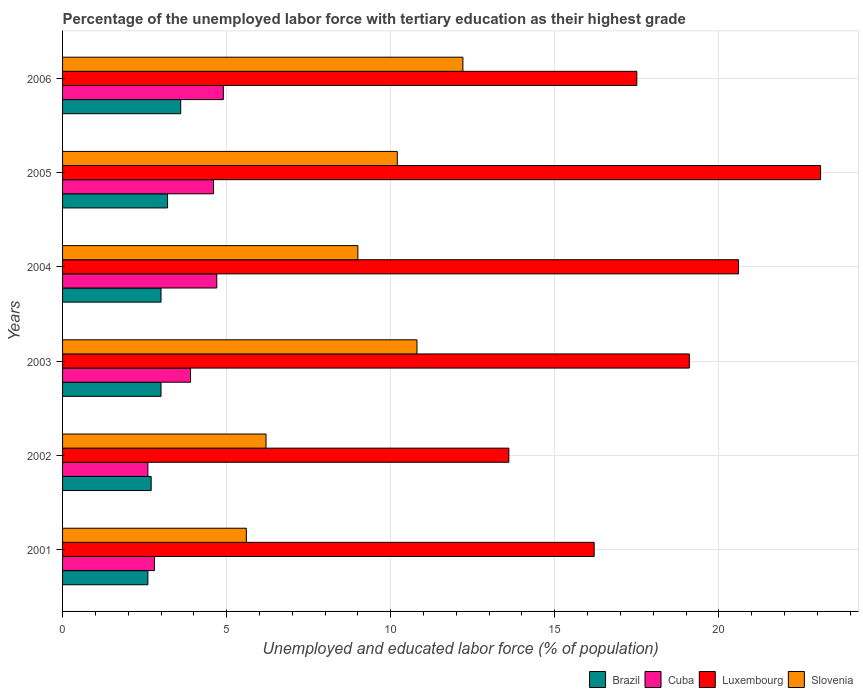How many different coloured bars are there?
Ensure brevity in your answer.  4. How many groups of bars are there?
Your response must be concise. 6. Are the number of bars on each tick of the Y-axis equal?
Keep it short and to the point. Yes. What is the label of the 1st group of bars from the top?
Give a very brief answer. 2006. What is the percentage of the unemployed labor force with tertiary education in Brazil in 2002?
Offer a terse response. 2.7. Across all years, what is the maximum percentage of the unemployed labor force with tertiary education in Slovenia?
Your response must be concise. 12.2. Across all years, what is the minimum percentage of the unemployed labor force with tertiary education in Cuba?
Your response must be concise. 2.6. In which year was the percentage of the unemployed labor force with tertiary education in Slovenia maximum?
Keep it short and to the point. 2006. What is the total percentage of the unemployed labor force with tertiary education in Slovenia in the graph?
Make the answer very short. 54. What is the difference between the percentage of the unemployed labor force with tertiary education in Slovenia in 2004 and that in 2006?
Your answer should be very brief. -3.2. What is the difference between the percentage of the unemployed labor force with tertiary education in Cuba in 2006 and the percentage of the unemployed labor force with tertiary education in Slovenia in 2001?
Keep it short and to the point. -0.7. What is the average percentage of the unemployed labor force with tertiary education in Slovenia per year?
Your answer should be compact. 9. In the year 2003, what is the difference between the percentage of the unemployed labor force with tertiary education in Slovenia and percentage of the unemployed labor force with tertiary education in Cuba?
Make the answer very short. 6.9. What is the ratio of the percentage of the unemployed labor force with tertiary education in Luxembourg in 2002 to that in 2006?
Provide a short and direct response. 0.78. Is the percentage of the unemployed labor force with tertiary education in Slovenia in 2004 less than that in 2005?
Offer a very short reply. Yes. What is the difference between the highest and the second highest percentage of the unemployed labor force with tertiary education in Cuba?
Offer a terse response. 0.2. What is the difference between the highest and the lowest percentage of the unemployed labor force with tertiary education in Cuba?
Offer a terse response. 2.3. In how many years, is the percentage of the unemployed labor force with tertiary education in Slovenia greater than the average percentage of the unemployed labor force with tertiary education in Slovenia taken over all years?
Your answer should be compact. 4. Is the sum of the percentage of the unemployed labor force with tertiary education in Brazil in 2002 and 2004 greater than the maximum percentage of the unemployed labor force with tertiary education in Slovenia across all years?
Your answer should be very brief. No. What does the 2nd bar from the top in 2001 represents?
Make the answer very short. Luxembourg. What does the 1st bar from the bottom in 2005 represents?
Keep it short and to the point. Brazil. How many bars are there?
Your response must be concise. 24. What is the difference between two consecutive major ticks on the X-axis?
Give a very brief answer. 5. How many legend labels are there?
Your answer should be very brief. 4. How are the legend labels stacked?
Give a very brief answer. Horizontal. What is the title of the graph?
Offer a very short reply. Percentage of the unemployed labor force with tertiary education as their highest grade. Does "Timor-Leste" appear as one of the legend labels in the graph?
Offer a very short reply. No. What is the label or title of the X-axis?
Ensure brevity in your answer.  Unemployed and educated labor force (% of population). What is the Unemployed and educated labor force (% of population) of Brazil in 2001?
Offer a terse response. 2.6. What is the Unemployed and educated labor force (% of population) in Cuba in 2001?
Your response must be concise. 2.8. What is the Unemployed and educated labor force (% of population) of Luxembourg in 2001?
Ensure brevity in your answer.  16.2. What is the Unemployed and educated labor force (% of population) of Slovenia in 2001?
Keep it short and to the point. 5.6. What is the Unemployed and educated labor force (% of population) of Brazil in 2002?
Make the answer very short. 2.7. What is the Unemployed and educated labor force (% of population) of Cuba in 2002?
Offer a very short reply. 2.6. What is the Unemployed and educated labor force (% of population) of Luxembourg in 2002?
Give a very brief answer. 13.6. What is the Unemployed and educated labor force (% of population) in Slovenia in 2002?
Keep it short and to the point. 6.2. What is the Unemployed and educated labor force (% of population) of Cuba in 2003?
Your answer should be very brief. 3.9. What is the Unemployed and educated labor force (% of population) in Luxembourg in 2003?
Ensure brevity in your answer.  19.1. What is the Unemployed and educated labor force (% of population) of Slovenia in 2003?
Offer a terse response. 10.8. What is the Unemployed and educated labor force (% of population) of Brazil in 2004?
Your answer should be very brief. 3. What is the Unemployed and educated labor force (% of population) of Cuba in 2004?
Your answer should be very brief. 4.7. What is the Unemployed and educated labor force (% of population) in Luxembourg in 2004?
Keep it short and to the point. 20.6. What is the Unemployed and educated labor force (% of population) of Slovenia in 2004?
Offer a very short reply. 9. What is the Unemployed and educated labor force (% of population) in Brazil in 2005?
Offer a very short reply. 3.2. What is the Unemployed and educated labor force (% of population) of Cuba in 2005?
Provide a short and direct response. 4.6. What is the Unemployed and educated labor force (% of population) in Luxembourg in 2005?
Your answer should be very brief. 23.1. What is the Unemployed and educated labor force (% of population) of Slovenia in 2005?
Make the answer very short. 10.2. What is the Unemployed and educated labor force (% of population) in Brazil in 2006?
Offer a very short reply. 3.6. What is the Unemployed and educated labor force (% of population) of Cuba in 2006?
Provide a short and direct response. 4.9. What is the Unemployed and educated labor force (% of population) in Slovenia in 2006?
Give a very brief answer. 12.2. Across all years, what is the maximum Unemployed and educated labor force (% of population) in Brazil?
Provide a succinct answer. 3.6. Across all years, what is the maximum Unemployed and educated labor force (% of population) of Cuba?
Your answer should be very brief. 4.9. Across all years, what is the maximum Unemployed and educated labor force (% of population) in Luxembourg?
Provide a short and direct response. 23.1. Across all years, what is the maximum Unemployed and educated labor force (% of population) in Slovenia?
Provide a succinct answer. 12.2. Across all years, what is the minimum Unemployed and educated labor force (% of population) in Brazil?
Provide a short and direct response. 2.6. Across all years, what is the minimum Unemployed and educated labor force (% of population) in Cuba?
Keep it short and to the point. 2.6. Across all years, what is the minimum Unemployed and educated labor force (% of population) in Luxembourg?
Make the answer very short. 13.6. Across all years, what is the minimum Unemployed and educated labor force (% of population) in Slovenia?
Provide a short and direct response. 5.6. What is the total Unemployed and educated labor force (% of population) of Brazil in the graph?
Your answer should be very brief. 18.1. What is the total Unemployed and educated labor force (% of population) of Luxembourg in the graph?
Your answer should be very brief. 110.1. What is the difference between the Unemployed and educated labor force (% of population) in Brazil in 2001 and that in 2002?
Your response must be concise. -0.1. What is the difference between the Unemployed and educated labor force (% of population) in Cuba in 2001 and that in 2002?
Offer a very short reply. 0.2. What is the difference between the Unemployed and educated labor force (% of population) in Luxembourg in 2001 and that in 2002?
Your answer should be very brief. 2.6. What is the difference between the Unemployed and educated labor force (% of population) of Slovenia in 2001 and that in 2003?
Offer a very short reply. -5.2. What is the difference between the Unemployed and educated labor force (% of population) of Cuba in 2001 and that in 2004?
Keep it short and to the point. -1.9. What is the difference between the Unemployed and educated labor force (% of population) of Luxembourg in 2001 and that in 2004?
Provide a succinct answer. -4.4. What is the difference between the Unemployed and educated labor force (% of population) in Cuba in 2001 and that in 2005?
Provide a short and direct response. -1.8. What is the difference between the Unemployed and educated labor force (% of population) of Luxembourg in 2001 and that in 2005?
Ensure brevity in your answer.  -6.9. What is the difference between the Unemployed and educated labor force (% of population) in Cuba in 2001 and that in 2006?
Give a very brief answer. -2.1. What is the difference between the Unemployed and educated labor force (% of population) in Luxembourg in 2001 and that in 2006?
Your response must be concise. -1.3. What is the difference between the Unemployed and educated labor force (% of population) in Slovenia in 2001 and that in 2006?
Give a very brief answer. -6.6. What is the difference between the Unemployed and educated labor force (% of population) in Brazil in 2002 and that in 2003?
Ensure brevity in your answer.  -0.3. What is the difference between the Unemployed and educated labor force (% of population) in Luxembourg in 2002 and that in 2003?
Offer a terse response. -5.5. What is the difference between the Unemployed and educated labor force (% of population) of Slovenia in 2002 and that in 2003?
Your answer should be compact. -4.6. What is the difference between the Unemployed and educated labor force (% of population) in Slovenia in 2002 and that in 2004?
Provide a short and direct response. -2.8. What is the difference between the Unemployed and educated labor force (% of population) of Brazil in 2002 and that in 2005?
Your answer should be compact. -0.5. What is the difference between the Unemployed and educated labor force (% of population) of Cuba in 2002 and that in 2005?
Your answer should be compact. -2. What is the difference between the Unemployed and educated labor force (% of population) in Luxembourg in 2002 and that in 2005?
Keep it short and to the point. -9.5. What is the difference between the Unemployed and educated labor force (% of population) of Slovenia in 2002 and that in 2005?
Give a very brief answer. -4. What is the difference between the Unemployed and educated labor force (% of population) of Luxembourg in 2002 and that in 2006?
Provide a short and direct response. -3.9. What is the difference between the Unemployed and educated labor force (% of population) of Brazil in 2003 and that in 2004?
Offer a terse response. 0. What is the difference between the Unemployed and educated labor force (% of population) of Slovenia in 2003 and that in 2005?
Give a very brief answer. 0.6. What is the difference between the Unemployed and educated labor force (% of population) of Cuba in 2003 and that in 2006?
Give a very brief answer. -1. What is the difference between the Unemployed and educated labor force (% of population) in Luxembourg in 2003 and that in 2006?
Provide a short and direct response. 1.6. What is the difference between the Unemployed and educated labor force (% of population) of Slovenia in 2004 and that in 2005?
Offer a terse response. -1.2. What is the difference between the Unemployed and educated labor force (% of population) of Cuba in 2004 and that in 2006?
Offer a very short reply. -0.2. What is the difference between the Unemployed and educated labor force (% of population) of Slovenia in 2005 and that in 2006?
Your answer should be very brief. -2. What is the difference between the Unemployed and educated labor force (% of population) in Brazil in 2001 and the Unemployed and educated labor force (% of population) in Slovenia in 2002?
Your response must be concise. -3.6. What is the difference between the Unemployed and educated labor force (% of population) of Cuba in 2001 and the Unemployed and educated labor force (% of population) of Luxembourg in 2002?
Your answer should be very brief. -10.8. What is the difference between the Unemployed and educated labor force (% of population) of Cuba in 2001 and the Unemployed and educated labor force (% of population) of Slovenia in 2002?
Make the answer very short. -3.4. What is the difference between the Unemployed and educated labor force (% of population) of Brazil in 2001 and the Unemployed and educated labor force (% of population) of Cuba in 2003?
Offer a very short reply. -1.3. What is the difference between the Unemployed and educated labor force (% of population) in Brazil in 2001 and the Unemployed and educated labor force (% of population) in Luxembourg in 2003?
Offer a terse response. -16.5. What is the difference between the Unemployed and educated labor force (% of population) in Brazil in 2001 and the Unemployed and educated labor force (% of population) in Slovenia in 2003?
Your answer should be compact. -8.2. What is the difference between the Unemployed and educated labor force (% of population) of Cuba in 2001 and the Unemployed and educated labor force (% of population) of Luxembourg in 2003?
Your answer should be compact. -16.3. What is the difference between the Unemployed and educated labor force (% of population) of Cuba in 2001 and the Unemployed and educated labor force (% of population) of Slovenia in 2003?
Keep it short and to the point. -8. What is the difference between the Unemployed and educated labor force (% of population) of Luxembourg in 2001 and the Unemployed and educated labor force (% of population) of Slovenia in 2003?
Your answer should be compact. 5.4. What is the difference between the Unemployed and educated labor force (% of population) of Brazil in 2001 and the Unemployed and educated labor force (% of population) of Cuba in 2004?
Your answer should be very brief. -2.1. What is the difference between the Unemployed and educated labor force (% of population) of Cuba in 2001 and the Unemployed and educated labor force (% of population) of Luxembourg in 2004?
Offer a very short reply. -17.8. What is the difference between the Unemployed and educated labor force (% of population) in Cuba in 2001 and the Unemployed and educated labor force (% of population) in Slovenia in 2004?
Ensure brevity in your answer.  -6.2. What is the difference between the Unemployed and educated labor force (% of population) of Brazil in 2001 and the Unemployed and educated labor force (% of population) of Cuba in 2005?
Ensure brevity in your answer.  -2. What is the difference between the Unemployed and educated labor force (% of population) in Brazil in 2001 and the Unemployed and educated labor force (% of population) in Luxembourg in 2005?
Provide a short and direct response. -20.5. What is the difference between the Unemployed and educated labor force (% of population) in Cuba in 2001 and the Unemployed and educated labor force (% of population) in Luxembourg in 2005?
Provide a succinct answer. -20.3. What is the difference between the Unemployed and educated labor force (% of population) in Cuba in 2001 and the Unemployed and educated labor force (% of population) in Slovenia in 2005?
Give a very brief answer. -7.4. What is the difference between the Unemployed and educated labor force (% of population) of Luxembourg in 2001 and the Unemployed and educated labor force (% of population) of Slovenia in 2005?
Offer a terse response. 6. What is the difference between the Unemployed and educated labor force (% of population) in Brazil in 2001 and the Unemployed and educated labor force (% of population) in Cuba in 2006?
Your response must be concise. -2.3. What is the difference between the Unemployed and educated labor force (% of population) in Brazil in 2001 and the Unemployed and educated labor force (% of population) in Luxembourg in 2006?
Your answer should be very brief. -14.9. What is the difference between the Unemployed and educated labor force (% of population) in Brazil in 2001 and the Unemployed and educated labor force (% of population) in Slovenia in 2006?
Provide a succinct answer. -9.6. What is the difference between the Unemployed and educated labor force (% of population) in Cuba in 2001 and the Unemployed and educated labor force (% of population) in Luxembourg in 2006?
Offer a terse response. -14.7. What is the difference between the Unemployed and educated labor force (% of population) in Brazil in 2002 and the Unemployed and educated labor force (% of population) in Luxembourg in 2003?
Ensure brevity in your answer.  -16.4. What is the difference between the Unemployed and educated labor force (% of population) of Brazil in 2002 and the Unemployed and educated labor force (% of population) of Slovenia in 2003?
Provide a succinct answer. -8.1. What is the difference between the Unemployed and educated labor force (% of population) of Cuba in 2002 and the Unemployed and educated labor force (% of population) of Luxembourg in 2003?
Your response must be concise. -16.5. What is the difference between the Unemployed and educated labor force (% of population) in Luxembourg in 2002 and the Unemployed and educated labor force (% of population) in Slovenia in 2003?
Provide a succinct answer. 2.8. What is the difference between the Unemployed and educated labor force (% of population) of Brazil in 2002 and the Unemployed and educated labor force (% of population) of Luxembourg in 2004?
Keep it short and to the point. -17.9. What is the difference between the Unemployed and educated labor force (% of population) in Brazil in 2002 and the Unemployed and educated labor force (% of population) in Slovenia in 2004?
Provide a succinct answer. -6.3. What is the difference between the Unemployed and educated labor force (% of population) of Cuba in 2002 and the Unemployed and educated labor force (% of population) of Slovenia in 2004?
Provide a short and direct response. -6.4. What is the difference between the Unemployed and educated labor force (% of population) of Brazil in 2002 and the Unemployed and educated labor force (% of population) of Luxembourg in 2005?
Provide a succinct answer. -20.4. What is the difference between the Unemployed and educated labor force (% of population) in Cuba in 2002 and the Unemployed and educated labor force (% of population) in Luxembourg in 2005?
Keep it short and to the point. -20.5. What is the difference between the Unemployed and educated labor force (% of population) of Brazil in 2002 and the Unemployed and educated labor force (% of population) of Cuba in 2006?
Your answer should be very brief. -2.2. What is the difference between the Unemployed and educated labor force (% of population) of Brazil in 2002 and the Unemployed and educated labor force (% of population) of Luxembourg in 2006?
Give a very brief answer. -14.8. What is the difference between the Unemployed and educated labor force (% of population) of Cuba in 2002 and the Unemployed and educated labor force (% of population) of Luxembourg in 2006?
Make the answer very short. -14.9. What is the difference between the Unemployed and educated labor force (% of population) of Cuba in 2002 and the Unemployed and educated labor force (% of population) of Slovenia in 2006?
Give a very brief answer. -9.6. What is the difference between the Unemployed and educated labor force (% of population) in Brazil in 2003 and the Unemployed and educated labor force (% of population) in Luxembourg in 2004?
Your response must be concise. -17.6. What is the difference between the Unemployed and educated labor force (% of population) of Cuba in 2003 and the Unemployed and educated labor force (% of population) of Luxembourg in 2004?
Your response must be concise. -16.7. What is the difference between the Unemployed and educated labor force (% of population) in Cuba in 2003 and the Unemployed and educated labor force (% of population) in Slovenia in 2004?
Keep it short and to the point. -5.1. What is the difference between the Unemployed and educated labor force (% of population) of Brazil in 2003 and the Unemployed and educated labor force (% of population) of Luxembourg in 2005?
Provide a short and direct response. -20.1. What is the difference between the Unemployed and educated labor force (% of population) of Cuba in 2003 and the Unemployed and educated labor force (% of population) of Luxembourg in 2005?
Give a very brief answer. -19.2. What is the difference between the Unemployed and educated labor force (% of population) of Cuba in 2003 and the Unemployed and educated labor force (% of population) of Slovenia in 2005?
Keep it short and to the point. -6.3. What is the difference between the Unemployed and educated labor force (% of population) of Brazil in 2003 and the Unemployed and educated labor force (% of population) of Cuba in 2006?
Keep it short and to the point. -1.9. What is the difference between the Unemployed and educated labor force (% of population) in Brazil in 2003 and the Unemployed and educated labor force (% of population) in Slovenia in 2006?
Provide a short and direct response. -9.2. What is the difference between the Unemployed and educated labor force (% of population) of Cuba in 2003 and the Unemployed and educated labor force (% of population) of Luxembourg in 2006?
Provide a succinct answer. -13.6. What is the difference between the Unemployed and educated labor force (% of population) in Brazil in 2004 and the Unemployed and educated labor force (% of population) in Luxembourg in 2005?
Ensure brevity in your answer.  -20.1. What is the difference between the Unemployed and educated labor force (% of population) in Brazil in 2004 and the Unemployed and educated labor force (% of population) in Slovenia in 2005?
Give a very brief answer. -7.2. What is the difference between the Unemployed and educated labor force (% of population) in Cuba in 2004 and the Unemployed and educated labor force (% of population) in Luxembourg in 2005?
Your answer should be very brief. -18.4. What is the difference between the Unemployed and educated labor force (% of population) in Cuba in 2004 and the Unemployed and educated labor force (% of population) in Slovenia in 2005?
Offer a very short reply. -5.5. What is the difference between the Unemployed and educated labor force (% of population) of Brazil in 2004 and the Unemployed and educated labor force (% of population) of Luxembourg in 2006?
Provide a succinct answer. -14.5. What is the difference between the Unemployed and educated labor force (% of population) of Brazil in 2004 and the Unemployed and educated labor force (% of population) of Slovenia in 2006?
Your response must be concise. -9.2. What is the difference between the Unemployed and educated labor force (% of population) in Cuba in 2004 and the Unemployed and educated labor force (% of population) in Slovenia in 2006?
Your answer should be very brief. -7.5. What is the difference between the Unemployed and educated labor force (% of population) in Brazil in 2005 and the Unemployed and educated labor force (% of population) in Cuba in 2006?
Provide a succinct answer. -1.7. What is the difference between the Unemployed and educated labor force (% of population) of Brazil in 2005 and the Unemployed and educated labor force (% of population) of Luxembourg in 2006?
Your response must be concise. -14.3. What is the difference between the Unemployed and educated labor force (% of population) of Brazil in 2005 and the Unemployed and educated labor force (% of population) of Slovenia in 2006?
Give a very brief answer. -9. What is the difference between the Unemployed and educated labor force (% of population) in Cuba in 2005 and the Unemployed and educated labor force (% of population) in Luxembourg in 2006?
Make the answer very short. -12.9. What is the average Unemployed and educated labor force (% of population) of Brazil per year?
Provide a succinct answer. 3.02. What is the average Unemployed and educated labor force (% of population) of Cuba per year?
Your response must be concise. 3.92. What is the average Unemployed and educated labor force (% of population) in Luxembourg per year?
Your answer should be very brief. 18.35. What is the average Unemployed and educated labor force (% of population) of Slovenia per year?
Your answer should be compact. 9. In the year 2001, what is the difference between the Unemployed and educated labor force (% of population) in Brazil and Unemployed and educated labor force (% of population) in Cuba?
Your answer should be compact. -0.2. In the year 2001, what is the difference between the Unemployed and educated labor force (% of population) of Brazil and Unemployed and educated labor force (% of population) of Luxembourg?
Your response must be concise. -13.6. In the year 2001, what is the difference between the Unemployed and educated labor force (% of population) in Brazil and Unemployed and educated labor force (% of population) in Slovenia?
Provide a short and direct response. -3. In the year 2001, what is the difference between the Unemployed and educated labor force (% of population) of Luxembourg and Unemployed and educated labor force (% of population) of Slovenia?
Your answer should be very brief. 10.6. In the year 2002, what is the difference between the Unemployed and educated labor force (% of population) of Brazil and Unemployed and educated labor force (% of population) of Luxembourg?
Make the answer very short. -10.9. In the year 2002, what is the difference between the Unemployed and educated labor force (% of population) of Brazil and Unemployed and educated labor force (% of population) of Slovenia?
Ensure brevity in your answer.  -3.5. In the year 2002, what is the difference between the Unemployed and educated labor force (% of population) in Cuba and Unemployed and educated labor force (% of population) in Luxembourg?
Offer a terse response. -11. In the year 2002, what is the difference between the Unemployed and educated labor force (% of population) in Cuba and Unemployed and educated labor force (% of population) in Slovenia?
Your response must be concise. -3.6. In the year 2002, what is the difference between the Unemployed and educated labor force (% of population) in Luxembourg and Unemployed and educated labor force (% of population) in Slovenia?
Give a very brief answer. 7.4. In the year 2003, what is the difference between the Unemployed and educated labor force (% of population) in Brazil and Unemployed and educated labor force (% of population) in Luxembourg?
Ensure brevity in your answer.  -16.1. In the year 2003, what is the difference between the Unemployed and educated labor force (% of population) of Cuba and Unemployed and educated labor force (% of population) of Luxembourg?
Ensure brevity in your answer.  -15.2. In the year 2004, what is the difference between the Unemployed and educated labor force (% of population) in Brazil and Unemployed and educated labor force (% of population) in Cuba?
Your response must be concise. -1.7. In the year 2004, what is the difference between the Unemployed and educated labor force (% of population) in Brazil and Unemployed and educated labor force (% of population) in Luxembourg?
Make the answer very short. -17.6. In the year 2004, what is the difference between the Unemployed and educated labor force (% of population) of Brazil and Unemployed and educated labor force (% of population) of Slovenia?
Ensure brevity in your answer.  -6. In the year 2004, what is the difference between the Unemployed and educated labor force (% of population) of Cuba and Unemployed and educated labor force (% of population) of Luxembourg?
Make the answer very short. -15.9. In the year 2004, what is the difference between the Unemployed and educated labor force (% of population) of Luxembourg and Unemployed and educated labor force (% of population) of Slovenia?
Offer a terse response. 11.6. In the year 2005, what is the difference between the Unemployed and educated labor force (% of population) in Brazil and Unemployed and educated labor force (% of population) in Luxembourg?
Offer a very short reply. -19.9. In the year 2005, what is the difference between the Unemployed and educated labor force (% of population) of Brazil and Unemployed and educated labor force (% of population) of Slovenia?
Offer a terse response. -7. In the year 2005, what is the difference between the Unemployed and educated labor force (% of population) in Cuba and Unemployed and educated labor force (% of population) in Luxembourg?
Offer a terse response. -18.5. In the year 2005, what is the difference between the Unemployed and educated labor force (% of population) of Luxembourg and Unemployed and educated labor force (% of population) of Slovenia?
Make the answer very short. 12.9. In the year 2006, what is the difference between the Unemployed and educated labor force (% of population) in Brazil and Unemployed and educated labor force (% of population) in Cuba?
Keep it short and to the point. -1.3. In the year 2006, what is the difference between the Unemployed and educated labor force (% of population) in Brazil and Unemployed and educated labor force (% of population) in Slovenia?
Provide a succinct answer. -8.6. In the year 2006, what is the difference between the Unemployed and educated labor force (% of population) of Cuba and Unemployed and educated labor force (% of population) of Slovenia?
Your response must be concise. -7.3. In the year 2006, what is the difference between the Unemployed and educated labor force (% of population) of Luxembourg and Unemployed and educated labor force (% of population) of Slovenia?
Keep it short and to the point. 5.3. What is the ratio of the Unemployed and educated labor force (% of population) in Brazil in 2001 to that in 2002?
Your answer should be very brief. 0.96. What is the ratio of the Unemployed and educated labor force (% of population) in Luxembourg in 2001 to that in 2002?
Ensure brevity in your answer.  1.19. What is the ratio of the Unemployed and educated labor force (% of population) in Slovenia in 2001 to that in 2002?
Make the answer very short. 0.9. What is the ratio of the Unemployed and educated labor force (% of population) in Brazil in 2001 to that in 2003?
Give a very brief answer. 0.87. What is the ratio of the Unemployed and educated labor force (% of population) of Cuba in 2001 to that in 2003?
Keep it short and to the point. 0.72. What is the ratio of the Unemployed and educated labor force (% of population) of Luxembourg in 2001 to that in 2003?
Make the answer very short. 0.85. What is the ratio of the Unemployed and educated labor force (% of population) of Slovenia in 2001 to that in 2003?
Offer a terse response. 0.52. What is the ratio of the Unemployed and educated labor force (% of population) in Brazil in 2001 to that in 2004?
Give a very brief answer. 0.87. What is the ratio of the Unemployed and educated labor force (% of population) of Cuba in 2001 to that in 2004?
Ensure brevity in your answer.  0.6. What is the ratio of the Unemployed and educated labor force (% of population) of Luxembourg in 2001 to that in 2004?
Offer a very short reply. 0.79. What is the ratio of the Unemployed and educated labor force (% of population) in Slovenia in 2001 to that in 2004?
Your answer should be very brief. 0.62. What is the ratio of the Unemployed and educated labor force (% of population) in Brazil in 2001 to that in 2005?
Your answer should be compact. 0.81. What is the ratio of the Unemployed and educated labor force (% of population) in Cuba in 2001 to that in 2005?
Ensure brevity in your answer.  0.61. What is the ratio of the Unemployed and educated labor force (% of population) in Luxembourg in 2001 to that in 2005?
Your answer should be compact. 0.7. What is the ratio of the Unemployed and educated labor force (% of population) in Slovenia in 2001 to that in 2005?
Provide a succinct answer. 0.55. What is the ratio of the Unemployed and educated labor force (% of population) of Brazil in 2001 to that in 2006?
Offer a very short reply. 0.72. What is the ratio of the Unemployed and educated labor force (% of population) in Cuba in 2001 to that in 2006?
Your answer should be very brief. 0.57. What is the ratio of the Unemployed and educated labor force (% of population) in Luxembourg in 2001 to that in 2006?
Keep it short and to the point. 0.93. What is the ratio of the Unemployed and educated labor force (% of population) in Slovenia in 2001 to that in 2006?
Your answer should be compact. 0.46. What is the ratio of the Unemployed and educated labor force (% of population) in Brazil in 2002 to that in 2003?
Provide a short and direct response. 0.9. What is the ratio of the Unemployed and educated labor force (% of population) of Cuba in 2002 to that in 2003?
Make the answer very short. 0.67. What is the ratio of the Unemployed and educated labor force (% of population) in Luxembourg in 2002 to that in 2003?
Provide a short and direct response. 0.71. What is the ratio of the Unemployed and educated labor force (% of population) of Slovenia in 2002 to that in 2003?
Your response must be concise. 0.57. What is the ratio of the Unemployed and educated labor force (% of population) in Brazil in 2002 to that in 2004?
Your answer should be very brief. 0.9. What is the ratio of the Unemployed and educated labor force (% of population) in Cuba in 2002 to that in 2004?
Provide a succinct answer. 0.55. What is the ratio of the Unemployed and educated labor force (% of population) of Luxembourg in 2002 to that in 2004?
Give a very brief answer. 0.66. What is the ratio of the Unemployed and educated labor force (% of population) in Slovenia in 2002 to that in 2004?
Keep it short and to the point. 0.69. What is the ratio of the Unemployed and educated labor force (% of population) in Brazil in 2002 to that in 2005?
Offer a terse response. 0.84. What is the ratio of the Unemployed and educated labor force (% of population) of Cuba in 2002 to that in 2005?
Provide a short and direct response. 0.57. What is the ratio of the Unemployed and educated labor force (% of population) of Luxembourg in 2002 to that in 2005?
Your answer should be very brief. 0.59. What is the ratio of the Unemployed and educated labor force (% of population) in Slovenia in 2002 to that in 2005?
Provide a succinct answer. 0.61. What is the ratio of the Unemployed and educated labor force (% of population) of Cuba in 2002 to that in 2006?
Your answer should be very brief. 0.53. What is the ratio of the Unemployed and educated labor force (% of population) in Luxembourg in 2002 to that in 2006?
Provide a succinct answer. 0.78. What is the ratio of the Unemployed and educated labor force (% of population) of Slovenia in 2002 to that in 2006?
Ensure brevity in your answer.  0.51. What is the ratio of the Unemployed and educated labor force (% of population) of Cuba in 2003 to that in 2004?
Provide a succinct answer. 0.83. What is the ratio of the Unemployed and educated labor force (% of population) of Luxembourg in 2003 to that in 2004?
Provide a succinct answer. 0.93. What is the ratio of the Unemployed and educated labor force (% of population) in Brazil in 2003 to that in 2005?
Provide a succinct answer. 0.94. What is the ratio of the Unemployed and educated labor force (% of population) in Cuba in 2003 to that in 2005?
Provide a short and direct response. 0.85. What is the ratio of the Unemployed and educated labor force (% of population) in Luxembourg in 2003 to that in 2005?
Make the answer very short. 0.83. What is the ratio of the Unemployed and educated labor force (% of population) of Slovenia in 2003 to that in 2005?
Ensure brevity in your answer.  1.06. What is the ratio of the Unemployed and educated labor force (% of population) in Brazil in 2003 to that in 2006?
Provide a succinct answer. 0.83. What is the ratio of the Unemployed and educated labor force (% of population) of Cuba in 2003 to that in 2006?
Give a very brief answer. 0.8. What is the ratio of the Unemployed and educated labor force (% of population) in Luxembourg in 2003 to that in 2006?
Offer a very short reply. 1.09. What is the ratio of the Unemployed and educated labor force (% of population) of Slovenia in 2003 to that in 2006?
Provide a short and direct response. 0.89. What is the ratio of the Unemployed and educated labor force (% of population) in Cuba in 2004 to that in 2005?
Give a very brief answer. 1.02. What is the ratio of the Unemployed and educated labor force (% of population) of Luxembourg in 2004 to that in 2005?
Provide a short and direct response. 0.89. What is the ratio of the Unemployed and educated labor force (% of population) in Slovenia in 2004 to that in 2005?
Give a very brief answer. 0.88. What is the ratio of the Unemployed and educated labor force (% of population) in Cuba in 2004 to that in 2006?
Offer a very short reply. 0.96. What is the ratio of the Unemployed and educated labor force (% of population) in Luxembourg in 2004 to that in 2006?
Your answer should be very brief. 1.18. What is the ratio of the Unemployed and educated labor force (% of population) in Slovenia in 2004 to that in 2006?
Keep it short and to the point. 0.74. What is the ratio of the Unemployed and educated labor force (% of population) of Brazil in 2005 to that in 2006?
Make the answer very short. 0.89. What is the ratio of the Unemployed and educated labor force (% of population) in Cuba in 2005 to that in 2006?
Offer a terse response. 0.94. What is the ratio of the Unemployed and educated labor force (% of population) in Luxembourg in 2005 to that in 2006?
Provide a short and direct response. 1.32. What is the ratio of the Unemployed and educated labor force (% of population) in Slovenia in 2005 to that in 2006?
Your answer should be compact. 0.84. What is the difference between the highest and the second highest Unemployed and educated labor force (% of population) of Brazil?
Ensure brevity in your answer.  0.4. What is the difference between the highest and the second highest Unemployed and educated labor force (% of population) of Cuba?
Give a very brief answer. 0.2. What is the difference between the highest and the second highest Unemployed and educated labor force (% of population) in Luxembourg?
Give a very brief answer. 2.5. What is the difference between the highest and the second highest Unemployed and educated labor force (% of population) of Slovenia?
Offer a very short reply. 1.4. 